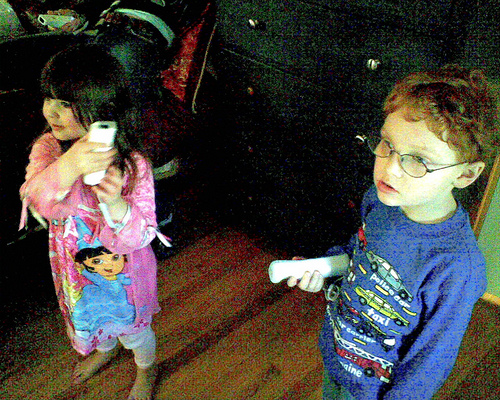<image>What are the children's names? It is unknown what the children's names are. It is not possible to determine from the image. What are the children's names? It is unknown what the children's names are. 